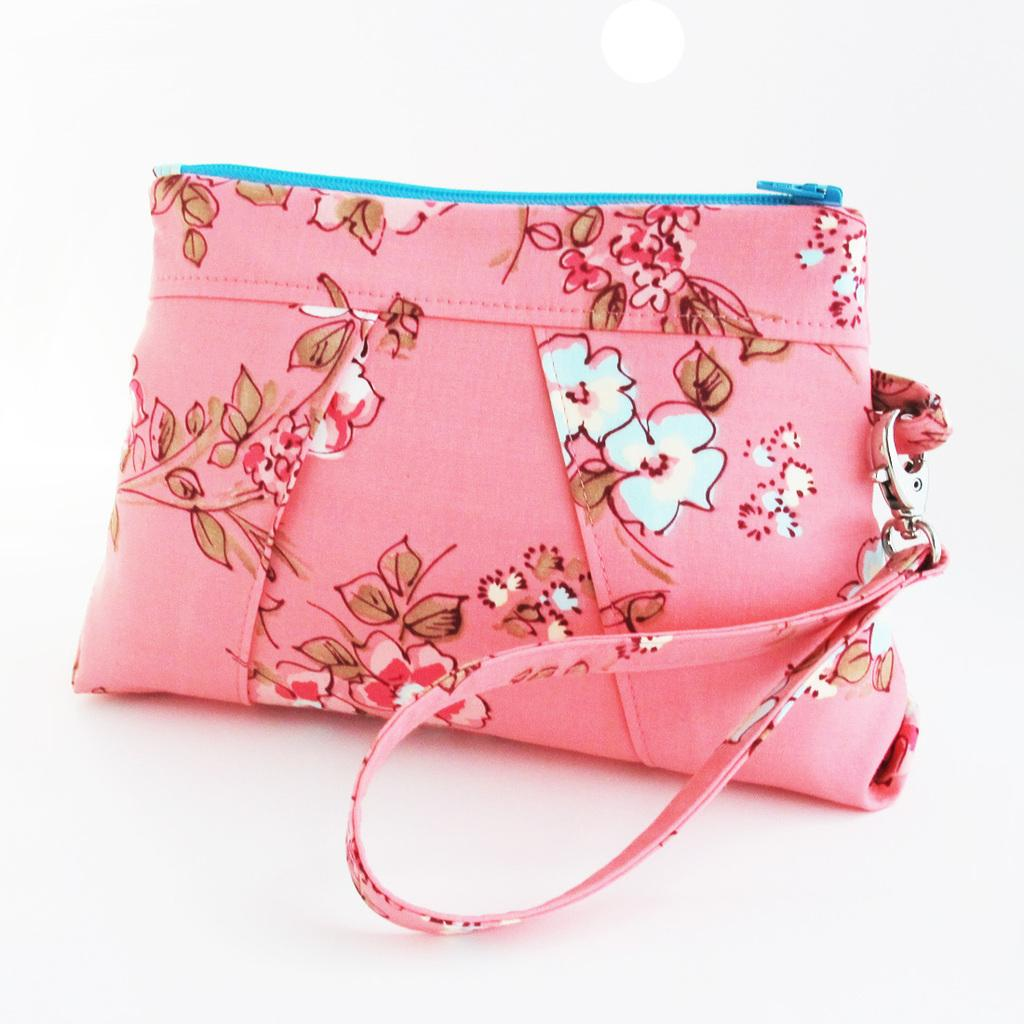What color is the bag in the image? The bag is pink in color. What material is the bag made of? The bag is made of cloth material. Is there any pattern or design on the bag? Yes, there is a design on the bag. How can the bag be carried? There is a handle attached to the bag for carrying. What color is the zip of the bag? The zip of the bag is blue in color. What type of appliance is being argued about in the image? There is no appliance or argument present in the image; it only features a pink bag with a design and a blue zip. 